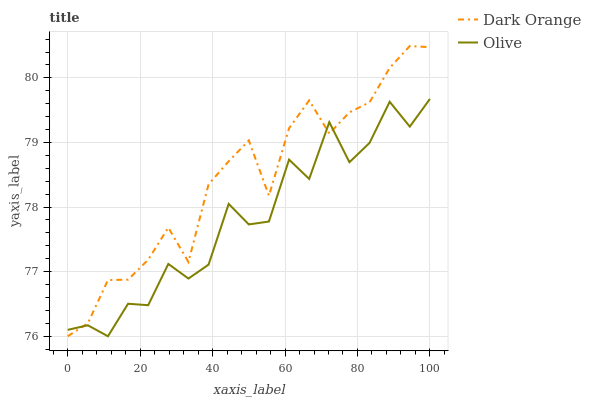Does Olive have the minimum area under the curve?
Answer yes or no. Yes. Does Dark Orange have the maximum area under the curve?
Answer yes or no. Yes. Does Dark Orange have the minimum area under the curve?
Answer yes or no. No. Is Dark Orange the smoothest?
Answer yes or no. Yes. Is Olive the roughest?
Answer yes or no. Yes. Is Dark Orange the roughest?
Answer yes or no. No. Does Olive have the lowest value?
Answer yes or no. Yes. Does Dark Orange have the highest value?
Answer yes or no. Yes. Does Dark Orange intersect Olive?
Answer yes or no. Yes. Is Dark Orange less than Olive?
Answer yes or no. No. Is Dark Orange greater than Olive?
Answer yes or no. No. 